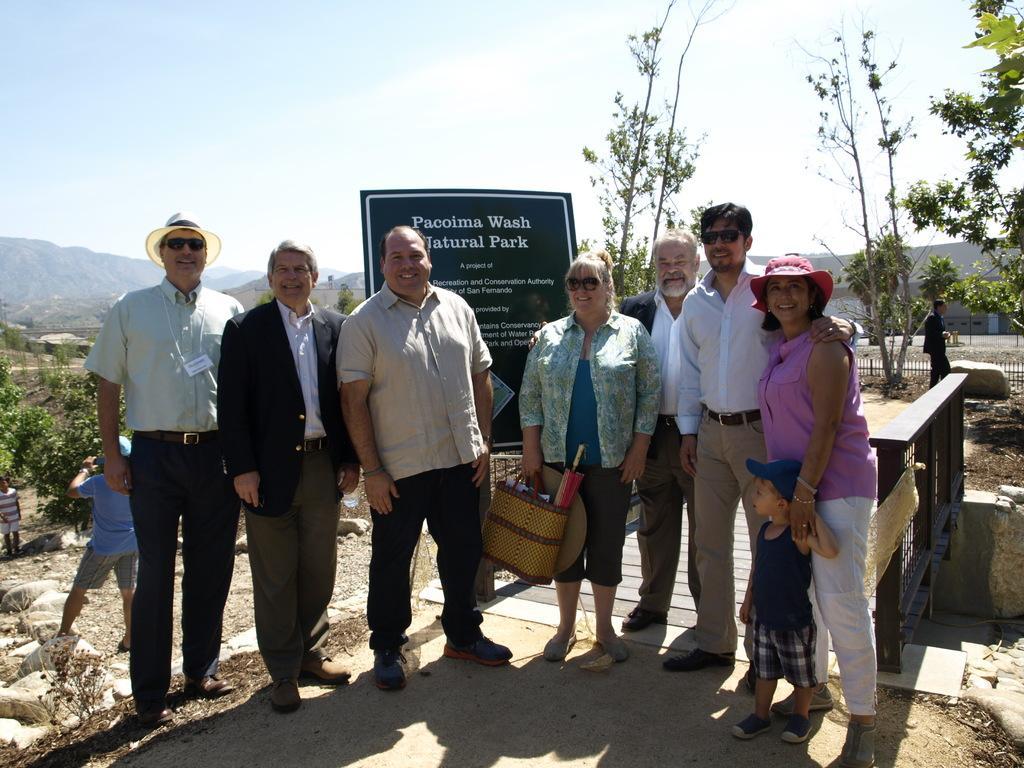Describe this image in one or two sentences. In this image there are group of people standing one beside the other. Behind them there is a board on which there is some text. In the background there are hills. At the bottom there are stones. In the background there is a person on the right side. At the top there is the sky. The woman in the middle is holding the bag. 